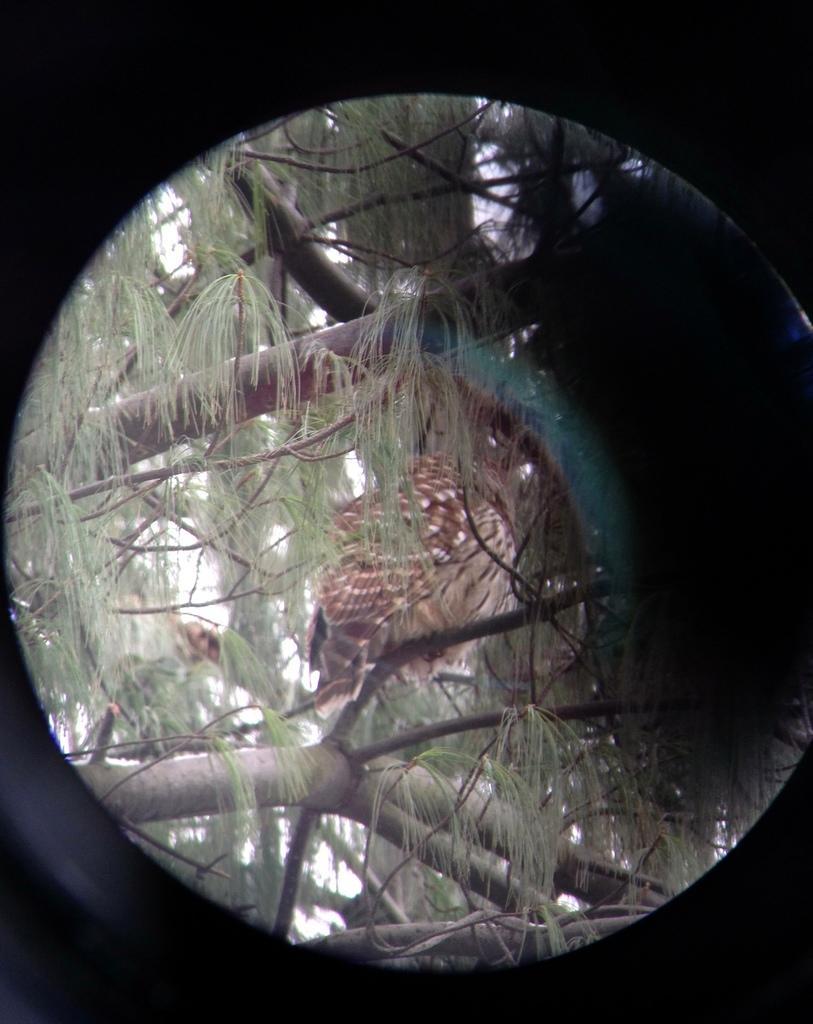Could you give a brief overview of what you see in this image? There's a hole. Through this hole, we can see there is bird standing on a branch of a tree which is having green color leaves. And the background is white in color. Outside this hole, the background is dark in color. 